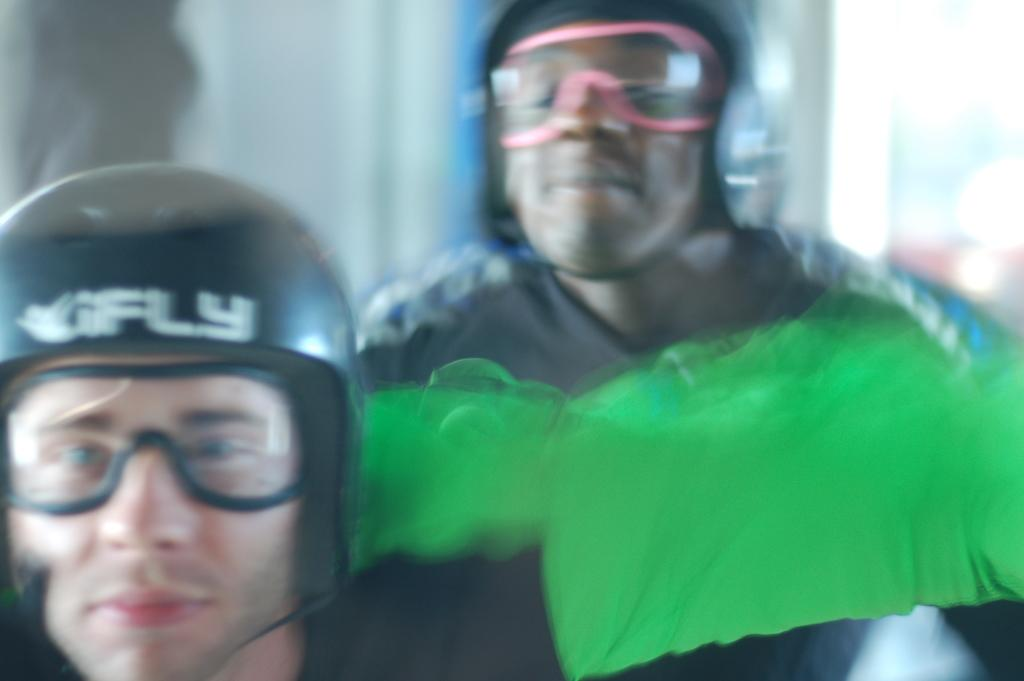How many people are in the image? There are two people in the image. What are the people wearing on their heads? The two people are wearing helmets. What can be seen in the background of the image? There is a wall in the background of the image. What type of tooth is visible in the image? There is no tooth visible in the image. What is the color of the sky in the image? The provided facts do not mention the sky, so we cannot determine its color from the image. 